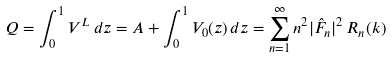Convert formula to latex. <formula><loc_0><loc_0><loc_500><loc_500>Q = \int _ { 0 } ^ { 1 } V ^ { L } \, d z = A + \int _ { 0 } ^ { 1 } V _ { 0 } ( z ) \, d z = \sum _ { n = 1 } ^ { \infty } n ^ { 2 } | \hat { F } _ { n } | ^ { 2 } \, R _ { n } ( k )</formula> 